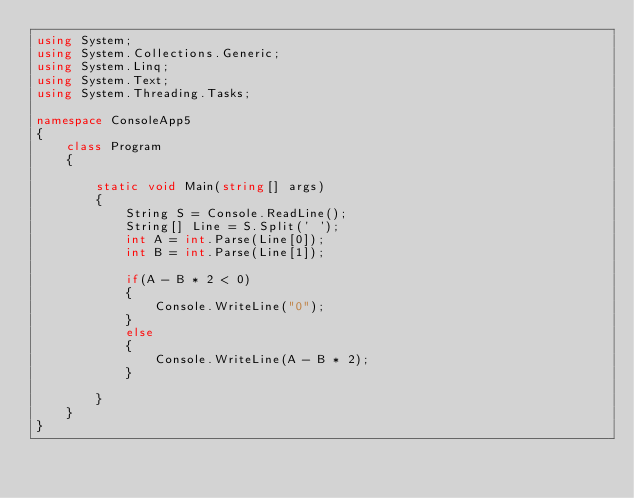Convert code to text. <code><loc_0><loc_0><loc_500><loc_500><_C#_>using System;
using System.Collections.Generic;
using System.Linq;
using System.Text;
using System.Threading.Tasks;

namespace ConsoleApp5
{
    class Program
    {

        static void Main(string[] args)
        {
            String S = Console.ReadLine();
            String[] Line = S.Split(' ');
            int A = int.Parse(Line[0]);
            int B = int.Parse(Line[1]);

            if(A - B * 2 < 0)
            {
                Console.WriteLine("0");
            }
            else
            {
                Console.WriteLine(A - B * 2);
            }

        }
    }
}</code> 